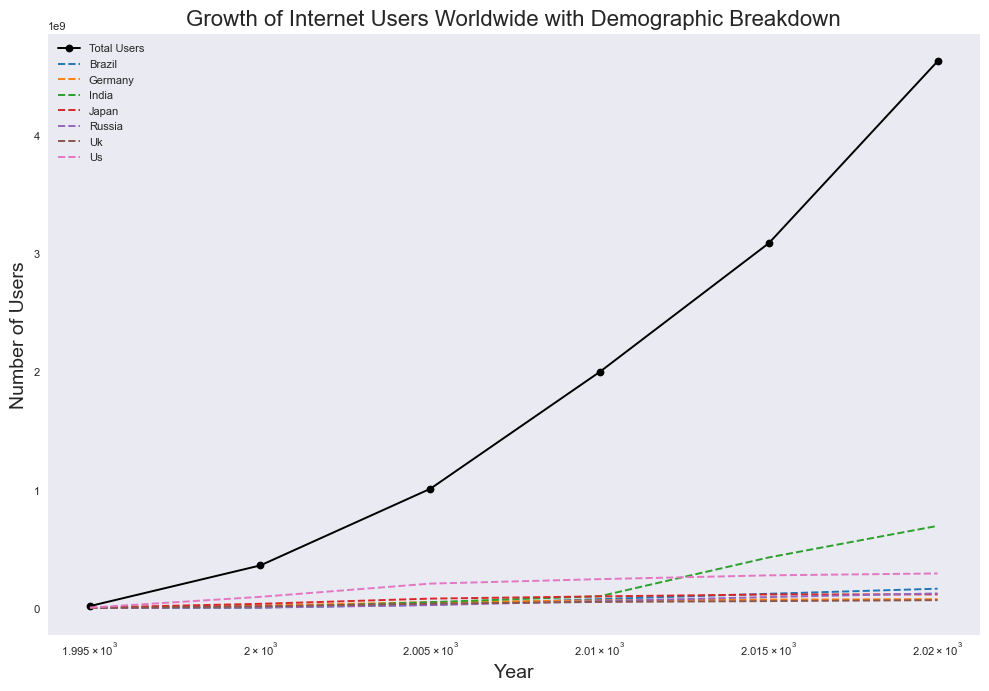What's the trend in the total number of internet users from 1995 to 2020? The trend for the total number of internet users from 1995 to 2020 can be observed as a continuous and significant increase. From barely 16.9 million users in 1995, the number grew exponentially to 4.63 billion users by 2020. The increase is particularly steep starting from 2000 onwards.
Answer: Increasing Which country has the highest number of internet users in 2020? In 2020, among the listed countries, India has the highest number of internet users, with 696 million users, as indicated by the highest peak in the graph for that year.
Answer: India How does the growth of internet users in the US compare to that of India between 2000 and 2020? From 2000 to 2020, India's internet user count increased from 5 million to 696 million, whereas the US saw growth from 95 million to 293 million. Therefore, the growth in India is significantly higher than in the US over this period.
Answer: India has higher growth What is the approximate ratio of internet users in Brazil to Japan in 2020? To find the ratio of internet users in Brazil to Japan in 2020, we divide Brazil's number of users (164 million) by Japan's number of users (116 million), which gives approximately 1.41:1.
Answer: 1.41:1 Among the countries listed, which one had the least number of internet users in 2015? In 2015, Germany had the least number of internet users, with 72 million users as shown on the graph.
Answer: Germany What is the visual clue that helps identify the 'Total Users' line on the chart? The 'Total Users' line can be identified by its distinct black color and solid line with circular markers, as opposed to other countries which have dashed lines with 'x' markers in different colors.
Answer: Black solid line with circles Calculate the overall increase in internet users in Russia from 1995 to 2020. In 1995, Russia had 350,000 internet users, which increased to 124 million by 2020. The overall increase is thus 124 million - 350,000 = 123.65 million.
Answer: 123.65 million Which two countries have similar user numbers in 2020, and what are their respective user counts? In 2020, Russia and Japan have similar user numbers, with Russia at 124 million and Japan at 116 million. Their user counts are quite close compared to the other countries.
Answer: Russia (124 million), Japan (116 million) 